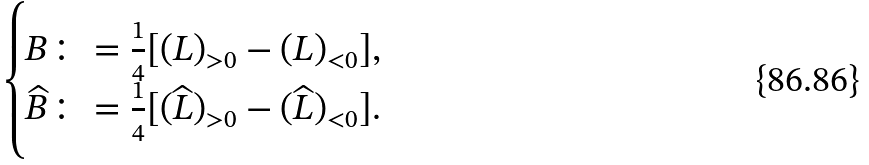Convert formula to latex. <formula><loc_0><loc_0><loc_500><loc_500>\begin{cases} B \colon = \frac { 1 } { 4 } [ ( L ) _ { > 0 } - ( L ) _ { < 0 } ] , \\ \widehat { B } \colon = \frac { 1 } { 4 } [ ( \widehat { L } ) _ { > 0 } - ( \widehat { L } ) _ { < 0 } ] . \end{cases}</formula> 